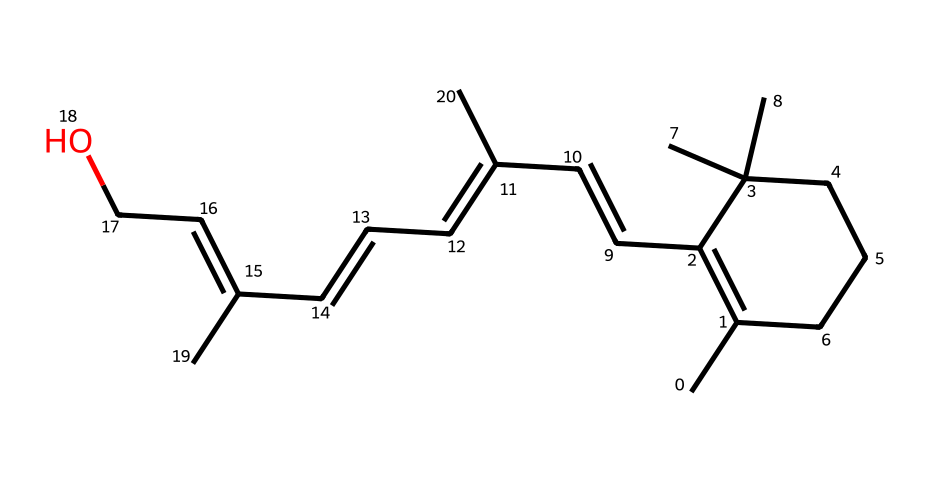What is the molecular formula of retinol? To determine the molecular formula, we count the number of carbon (C), hydrogen (H), and oxygen (O) atoms in the provided SMILES representation. There are 20 carbon atoms, 30 hydrogen atoms, and 1 oxygen atom. Therefore, the molecular formula is C20H30O.
Answer: C20H30O How many double bonds are present in the structure? By visually inspecting the SMILES representation, we identify the instances of double bonds. In this structure, there are 4 double bonds between carbon atoms that can be observed by searching for the '=' character. Hence, the total number of double bonds is 4.
Answer: 4 What functional group is indicated by the presence of the oxygen atom? The presence of oxygen in the structure typically indicates a hydroxyl group (-OH) in organic compounds. Upon examining the chemical structure, we can confirm that the oxygen is part of a hydroxyl group, which is characteristic of alcohols and is responsible for retinol's properties.
Answer: hydroxyl How many rings does the chemical structure contain? By analyzing the structure, we look for rings, which are indicated by the numbers in the SMILES notation. Here, “C1” and “CCC1” indicate there is one cyclic structure present within the molecule. Counting this leads to the conclusion of 1 ring.
Answer: 1 Is retinol considered a saturated or unsaturated compound? Unsaturated compounds have one or more double bonds present in their structure. Since we previously identified 4 double bonds in the retinol structure, we can classify this compound as unsaturated.
Answer: unsaturated What type of compound is retinol classified as? Retinol is recognized for its role in skin care, particularly as an anti-aging agent, making it classified as a vitamin A derivative. It is specifically known for its function as a retinoid in the cosmetic industry.
Answer: retinoid 